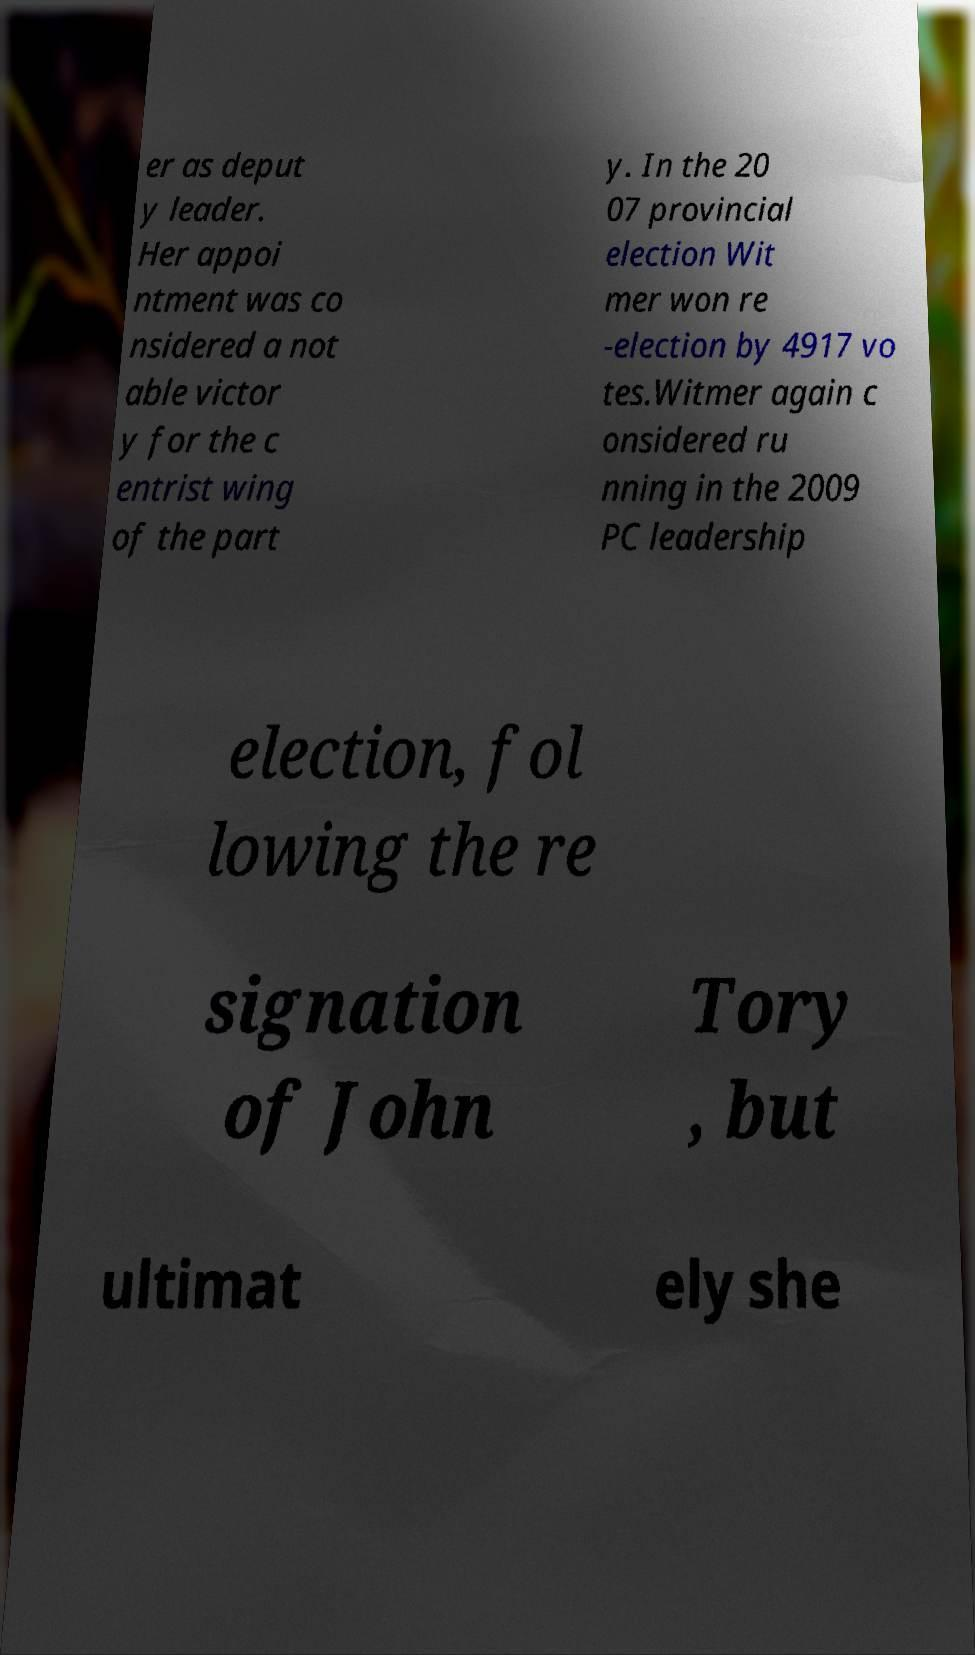There's text embedded in this image that I need extracted. Can you transcribe it verbatim? er as deput y leader. Her appoi ntment was co nsidered a not able victor y for the c entrist wing of the part y. In the 20 07 provincial election Wit mer won re -election by 4917 vo tes.Witmer again c onsidered ru nning in the 2009 PC leadership election, fol lowing the re signation of John Tory , but ultimat ely she 